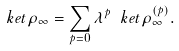<formula> <loc_0><loc_0><loc_500><loc_500>\ k e t { \rho _ { \infty } } = \sum _ { p = 0 } \lambda ^ { p } \ k e t { \rho _ { \infty } ^ { ( p ) } } .</formula> 